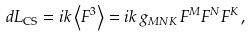Convert formula to latex. <formula><loc_0><loc_0><loc_500><loc_500>d L _ { \text {CS} } = i k \left \langle F ^ { 3 } \right \rangle = i k \, g _ { M N K } \, F ^ { M } F ^ { N } F ^ { K } \, ,</formula> 